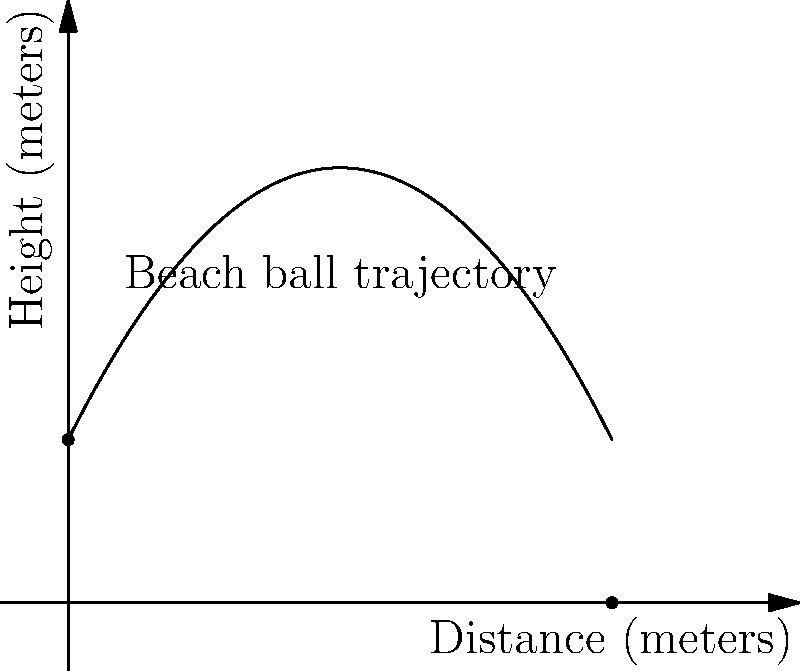A family is playing with a beach ball at the park. Dad tosses the ball to his child, and the trajectory of the ball can be modeled by the equation $h(x) = -0.2x^2 + 2x + 3$, where $h$ is the height of the ball in meters and $x$ is the horizontal distance in meters. How far away (in meters) is the child standing if they catch the ball just as it reaches the ground? Let's approach this step-by-step:

1) The ball reaches the ground when its height is 0. So, we need to solve the equation:

   $0 = -0.2x^2 + 2x + 3$

2) This is a quadratic equation. We can solve it using the quadratic formula:
   $x = \frac{-b \pm \sqrt{b^2 - 4ac}}{2a}$

   Where $a = -0.2$, $b = 2$, and $c = 3$

3) Plugging these values into the quadratic formula:

   $x = \frac{-2 \pm \sqrt{2^2 - 4(-0.2)(3)}}{2(-0.2)}$

4) Simplifying:

   $x = \frac{-2 \pm \sqrt{4 + 2.4}}{-0.4} = \frac{-2 \pm \sqrt{6.4}}{-0.4} = \frac{-2 \pm 2.53}{-0.4}$

5) This gives us two solutions:

   $x = \frac{-2 + 2.53}{-0.4} = -1.325$ or $x = \frac{-2 - 2.53}{-0.4} = 10$

6) Since distance can't be negative, we take the positive solution.

Therefore, the child is standing 10 meters away from where the ball was thrown.
Answer: 10 meters 